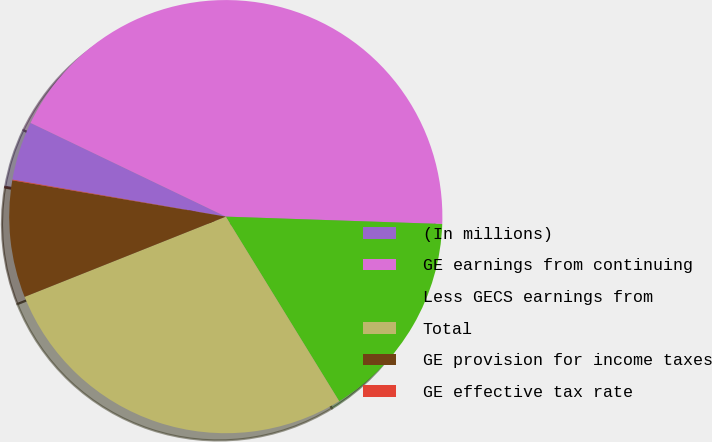<chart> <loc_0><loc_0><loc_500><loc_500><pie_chart><fcel>(In millions)<fcel>GE earnings from continuing<fcel>Less GECS earnings from<fcel>Total<fcel>GE provision for income taxes<fcel>GE effective tax rate<nl><fcel>4.39%<fcel>43.42%<fcel>15.69%<fcel>27.73%<fcel>8.72%<fcel>0.05%<nl></chart> 